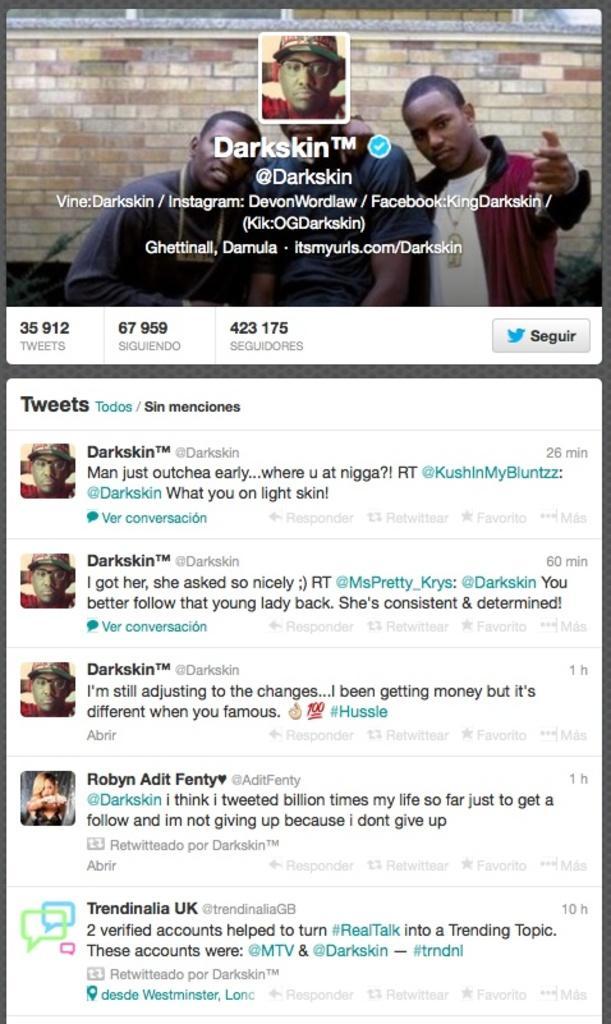Can you describe this image briefly? This is the page of a person's twitter account. We can see profile photo, cover photo and tweets. 